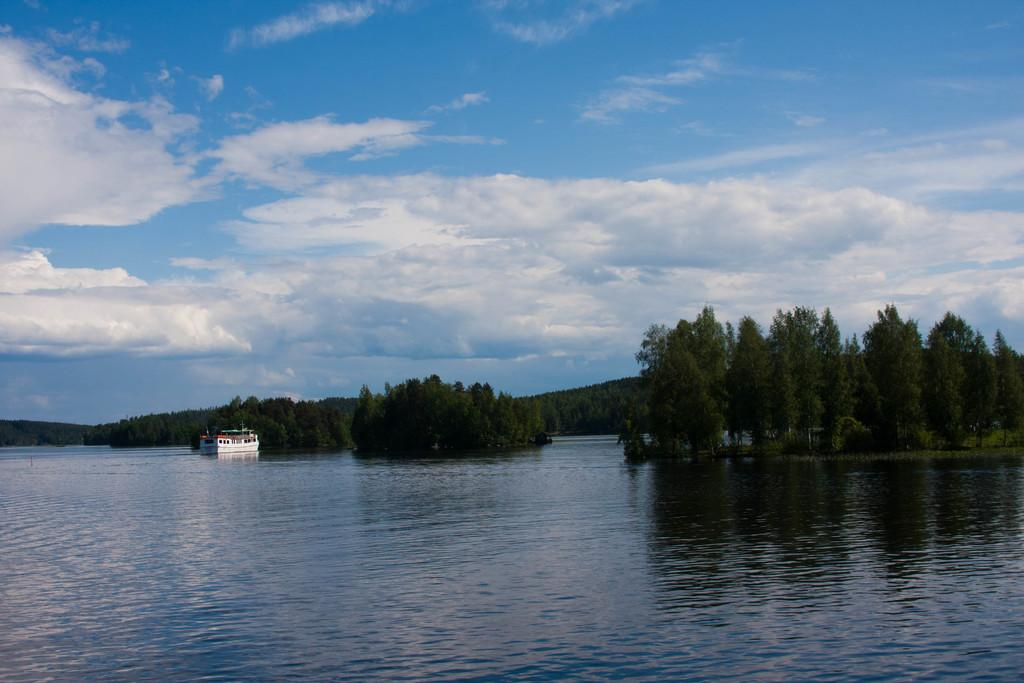What type of natural feature is at the bottom of the image? The image contains a sea at the bottom. What is floating on the sea in the image? There is a ship in the sea. What can be seen in the distance in the image? There are mountains and trees in the background of the image. What is visible at the top of the image? The sky is visible at the top of the image. What type of nerve can be seen controlling the ship in the image? There is no nerve present in the image, and the ship is not being controlled by any visible nerve. 